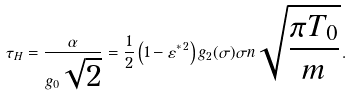Convert formula to latex. <formula><loc_0><loc_0><loc_500><loc_500>\tau _ { H } = \frac { \alpha } { g _ { 0 } \sqrt { 2 } } = \frac { 1 } { 2 } \left ( 1 - \varepsilon ^ { * \, 2 } \right ) g _ { 2 } ( \sigma ) \sigma n \sqrt { \frac { \pi T _ { 0 } } { m } } \, .</formula> 